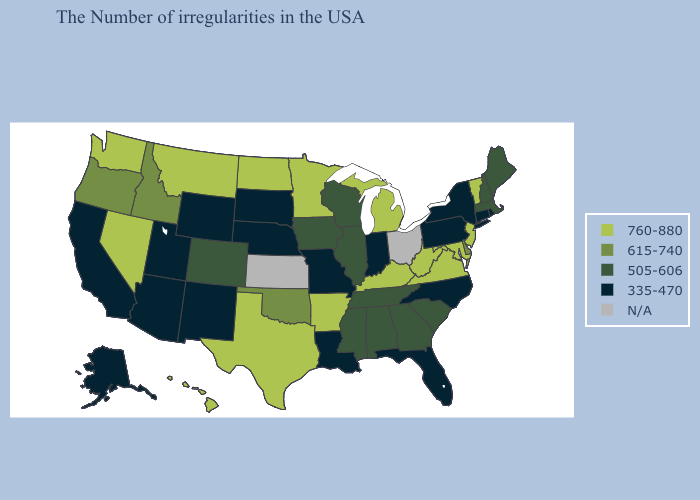Name the states that have a value in the range N/A?
Keep it brief. Ohio, Kansas. Name the states that have a value in the range 505-606?
Quick response, please. Maine, Massachusetts, New Hampshire, South Carolina, Georgia, Alabama, Tennessee, Wisconsin, Illinois, Mississippi, Iowa, Colorado. Name the states that have a value in the range 505-606?
Answer briefly. Maine, Massachusetts, New Hampshire, South Carolina, Georgia, Alabama, Tennessee, Wisconsin, Illinois, Mississippi, Iowa, Colorado. What is the value of Delaware?
Answer briefly. 615-740. Does the first symbol in the legend represent the smallest category?
Give a very brief answer. No. Name the states that have a value in the range 335-470?
Be succinct. Rhode Island, Connecticut, New York, Pennsylvania, North Carolina, Florida, Indiana, Louisiana, Missouri, Nebraska, South Dakota, Wyoming, New Mexico, Utah, Arizona, California, Alaska. Does Nevada have the highest value in the West?
Write a very short answer. Yes. Among the states that border Idaho , does Washington have the lowest value?
Write a very short answer. No. Name the states that have a value in the range 335-470?
Be succinct. Rhode Island, Connecticut, New York, Pennsylvania, North Carolina, Florida, Indiana, Louisiana, Missouri, Nebraska, South Dakota, Wyoming, New Mexico, Utah, Arizona, California, Alaska. Which states have the lowest value in the USA?
Give a very brief answer. Rhode Island, Connecticut, New York, Pennsylvania, North Carolina, Florida, Indiana, Louisiana, Missouri, Nebraska, South Dakota, Wyoming, New Mexico, Utah, Arizona, California, Alaska. Is the legend a continuous bar?
Answer briefly. No. Name the states that have a value in the range 335-470?
Write a very short answer. Rhode Island, Connecticut, New York, Pennsylvania, North Carolina, Florida, Indiana, Louisiana, Missouri, Nebraska, South Dakota, Wyoming, New Mexico, Utah, Arizona, California, Alaska. What is the highest value in states that border Washington?
Answer briefly. 615-740. 